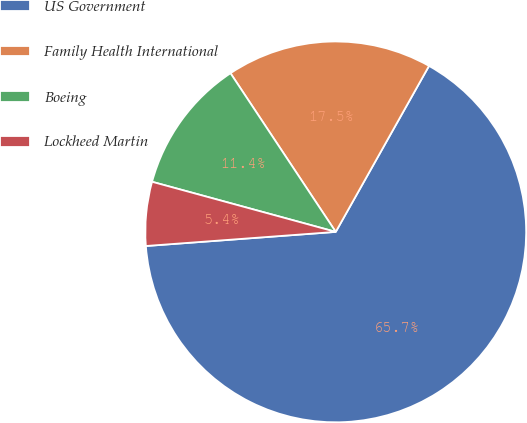Convert chart. <chart><loc_0><loc_0><loc_500><loc_500><pie_chart><fcel>US Government<fcel>Family Health International<fcel>Boeing<fcel>Lockheed Martin<nl><fcel>65.67%<fcel>17.47%<fcel>11.44%<fcel>5.42%<nl></chart> 